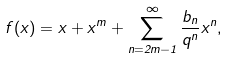<formula> <loc_0><loc_0><loc_500><loc_500>f ( x ) = x + x ^ { m } + \sum _ { n = 2 m - 1 } ^ { \infty } \frac { b _ { n } } { q ^ { n } } x ^ { n } ,</formula> 